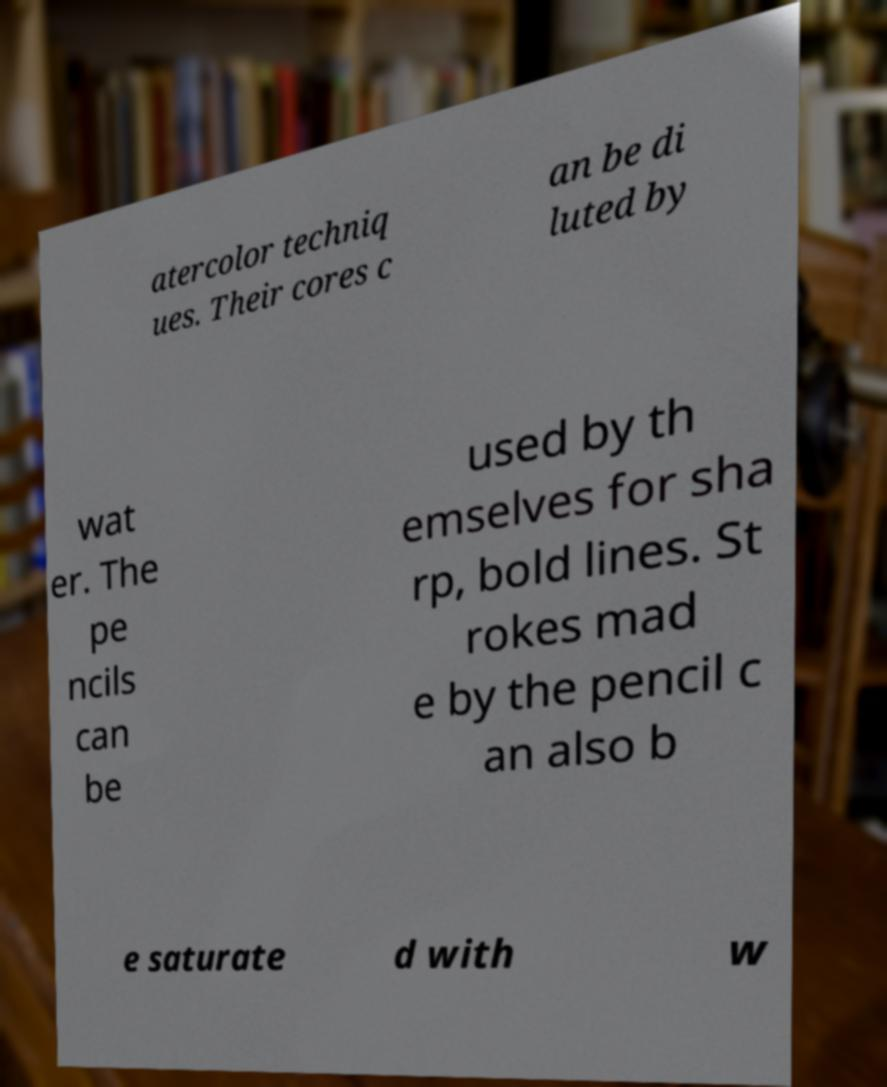I need the written content from this picture converted into text. Can you do that? atercolor techniq ues. Their cores c an be di luted by wat er. The pe ncils can be used by th emselves for sha rp, bold lines. St rokes mad e by the pencil c an also b e saturate d with w 